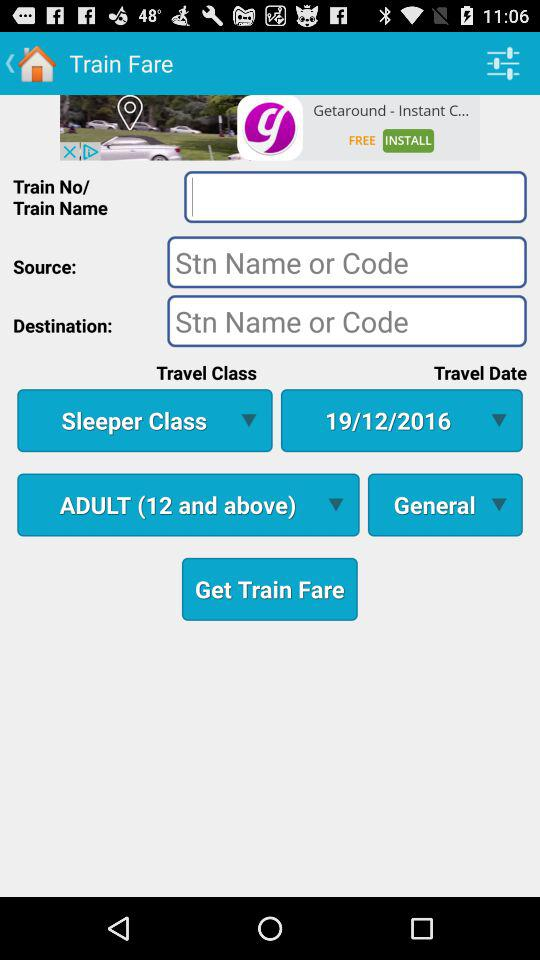What is the selected travel class? The selected travel class is "Sleeper Class". 